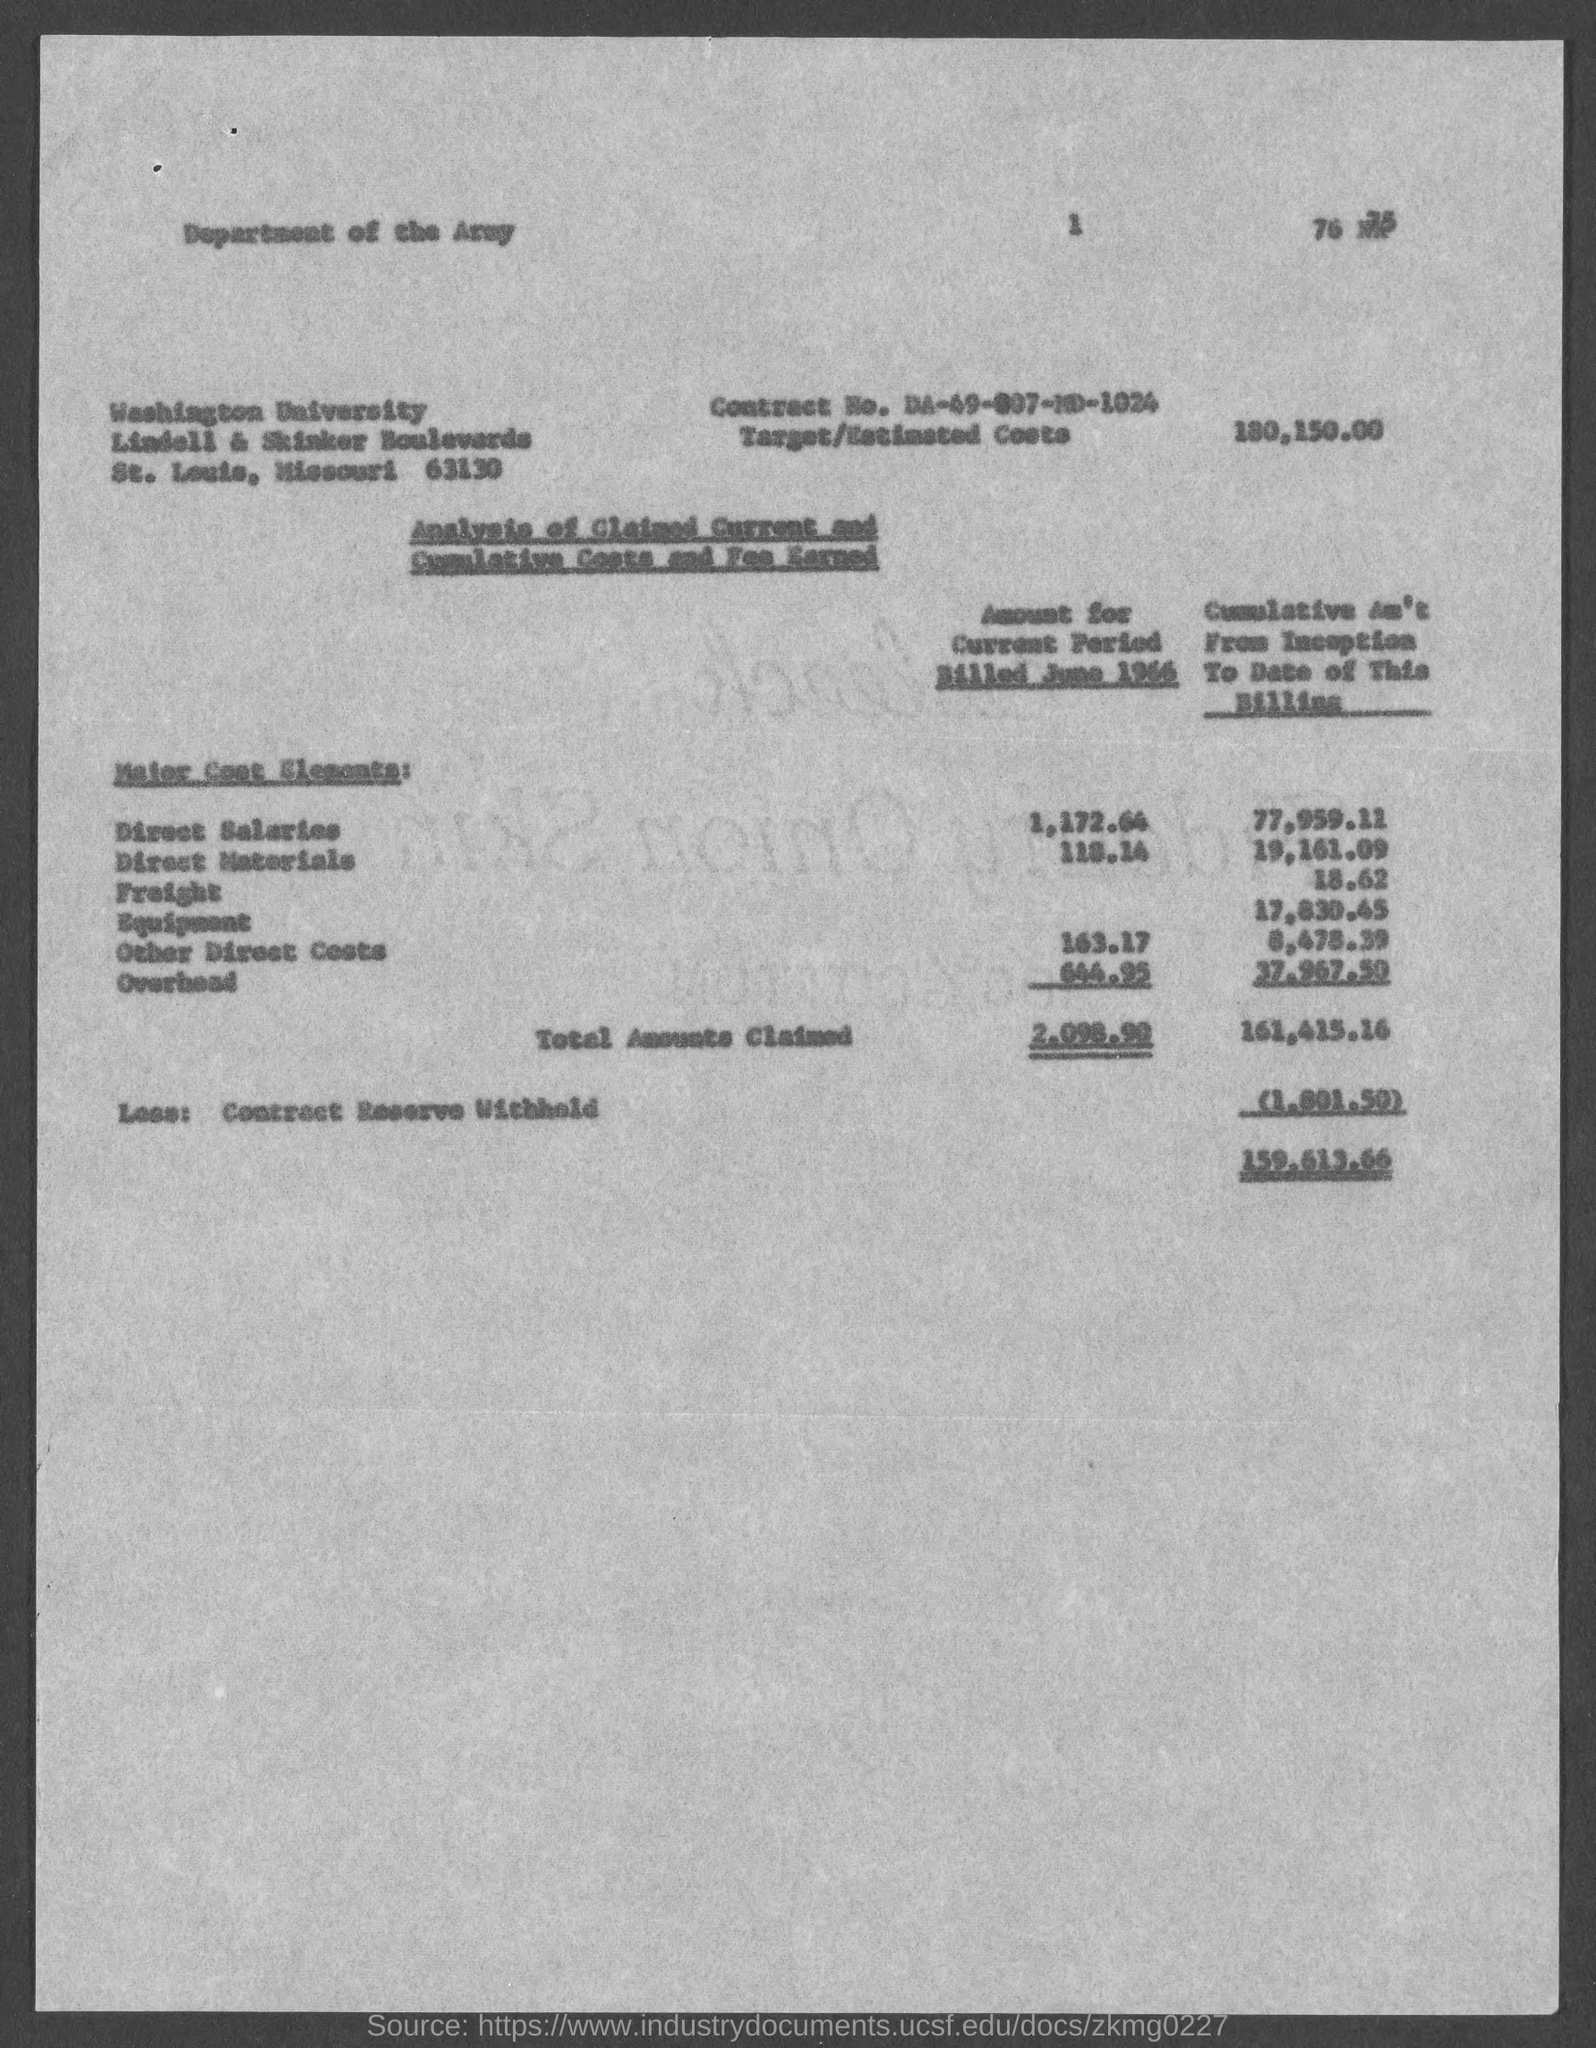Give some essential details in this illustration. The target cost estimate for the project is 180,150.00. Washington University is located in the state of Missouri. The contract number is DA-49-007-MD-1024. 